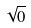<formula> <loc_0><loc_0><loc_500><loc_500>\sqrt { 0 }</formula> 